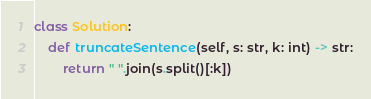Convert code to text. <code><loc_0><loc_0><loc_500><loc_500><_Python_>class Solution:
    def truncateSentence(self, s: str, k: int) -> str:
        return " ".join(s.split()[:k])</code> 